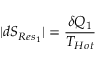<formula> <loc_0><loc_0><loc_500><loc_500>| d S _ { R e s _ { 1 } } | = { \frac { \delta Q _ { 1 } } { T _ { H o t } } }</formula> 